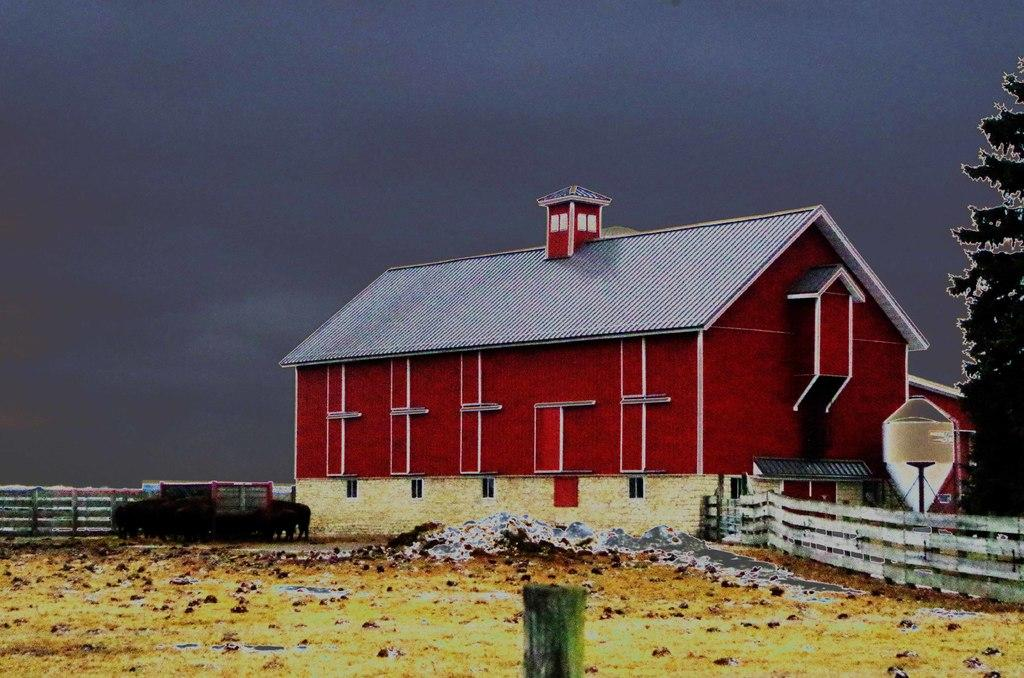What is the main structure in the middle of the image? There is a building in the middle of the image. What is the color of the building? The building is red in color. What type of vegetation is on the right side of the image? There is a tree on the right side of the image. What is visible at the top of the image? The sky is visible at the top of the image. What vehicle can be seen in the middle of the image? There is a car in the middle of the image. What is the name of the person standing next to the tree in the image? There is no person standing next to the tree in the tree in the image. 